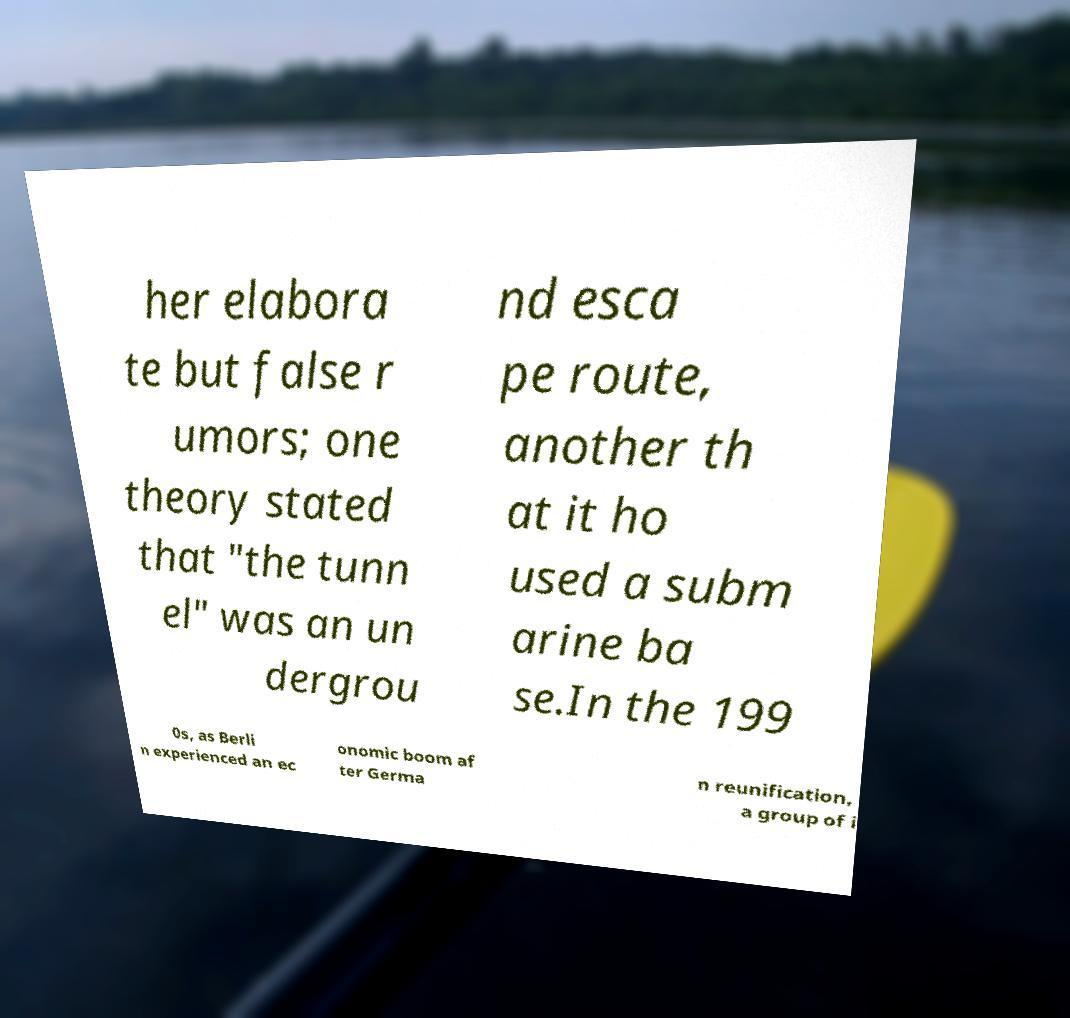What messages or text are displayed in this image? I need them in a readable, typed format. her elabora te but false r umors; one theory stated that "the tunn el" was an un dergrou nd esca pe route, another th at it ho used a subm arine ba se.In the 199 0s, as Berli n experienced an ec onomic boom af ter Germa n reunification, a group of i 